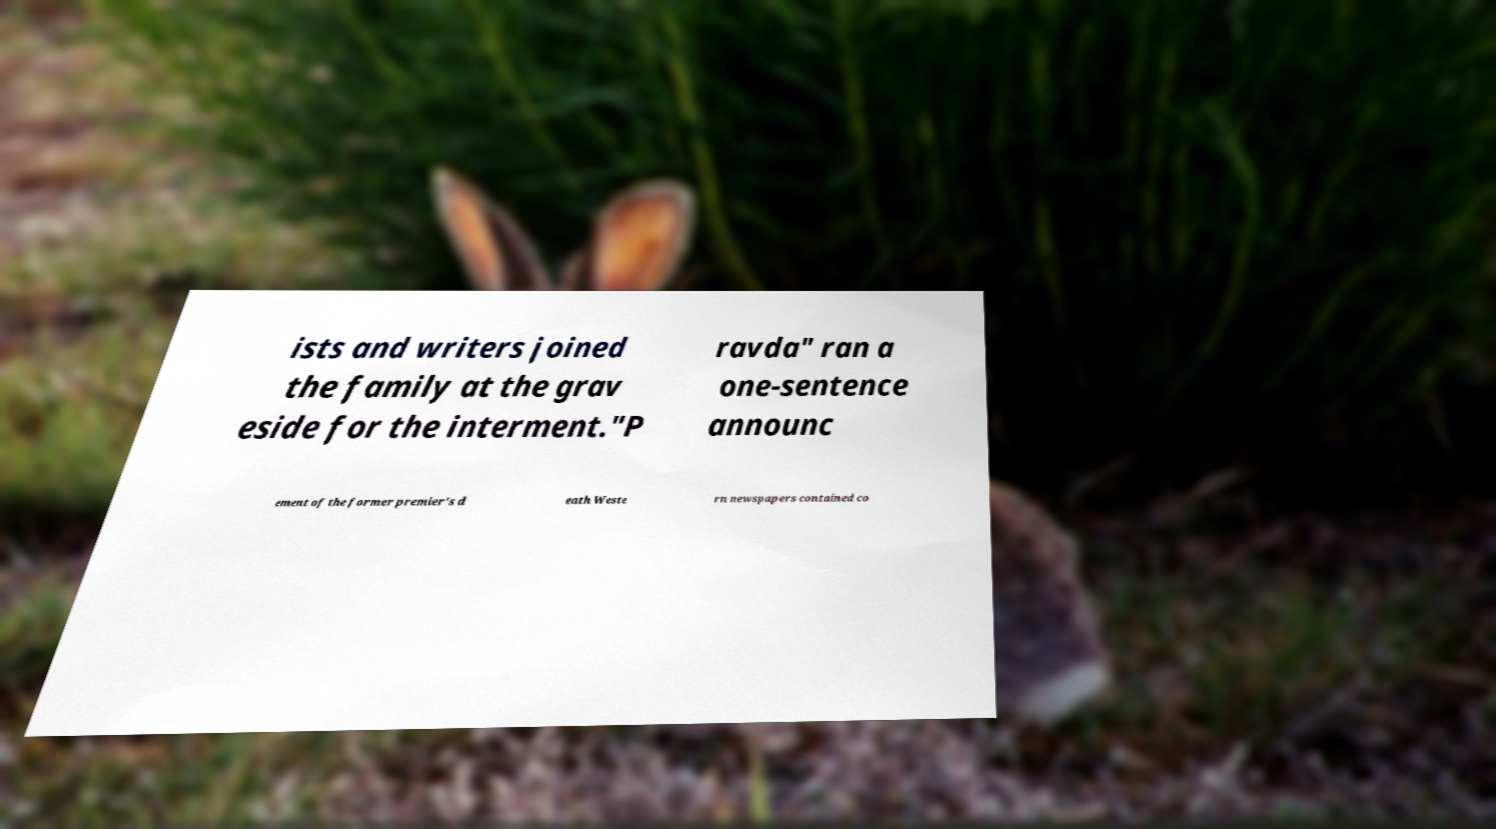Could you extract and type out the text from this image? ists and writers joined the family at the grav eside for the interment."P ravda" ran a one-sentence announc ement of the former premier's d eath Weste rn newspapers contained co 